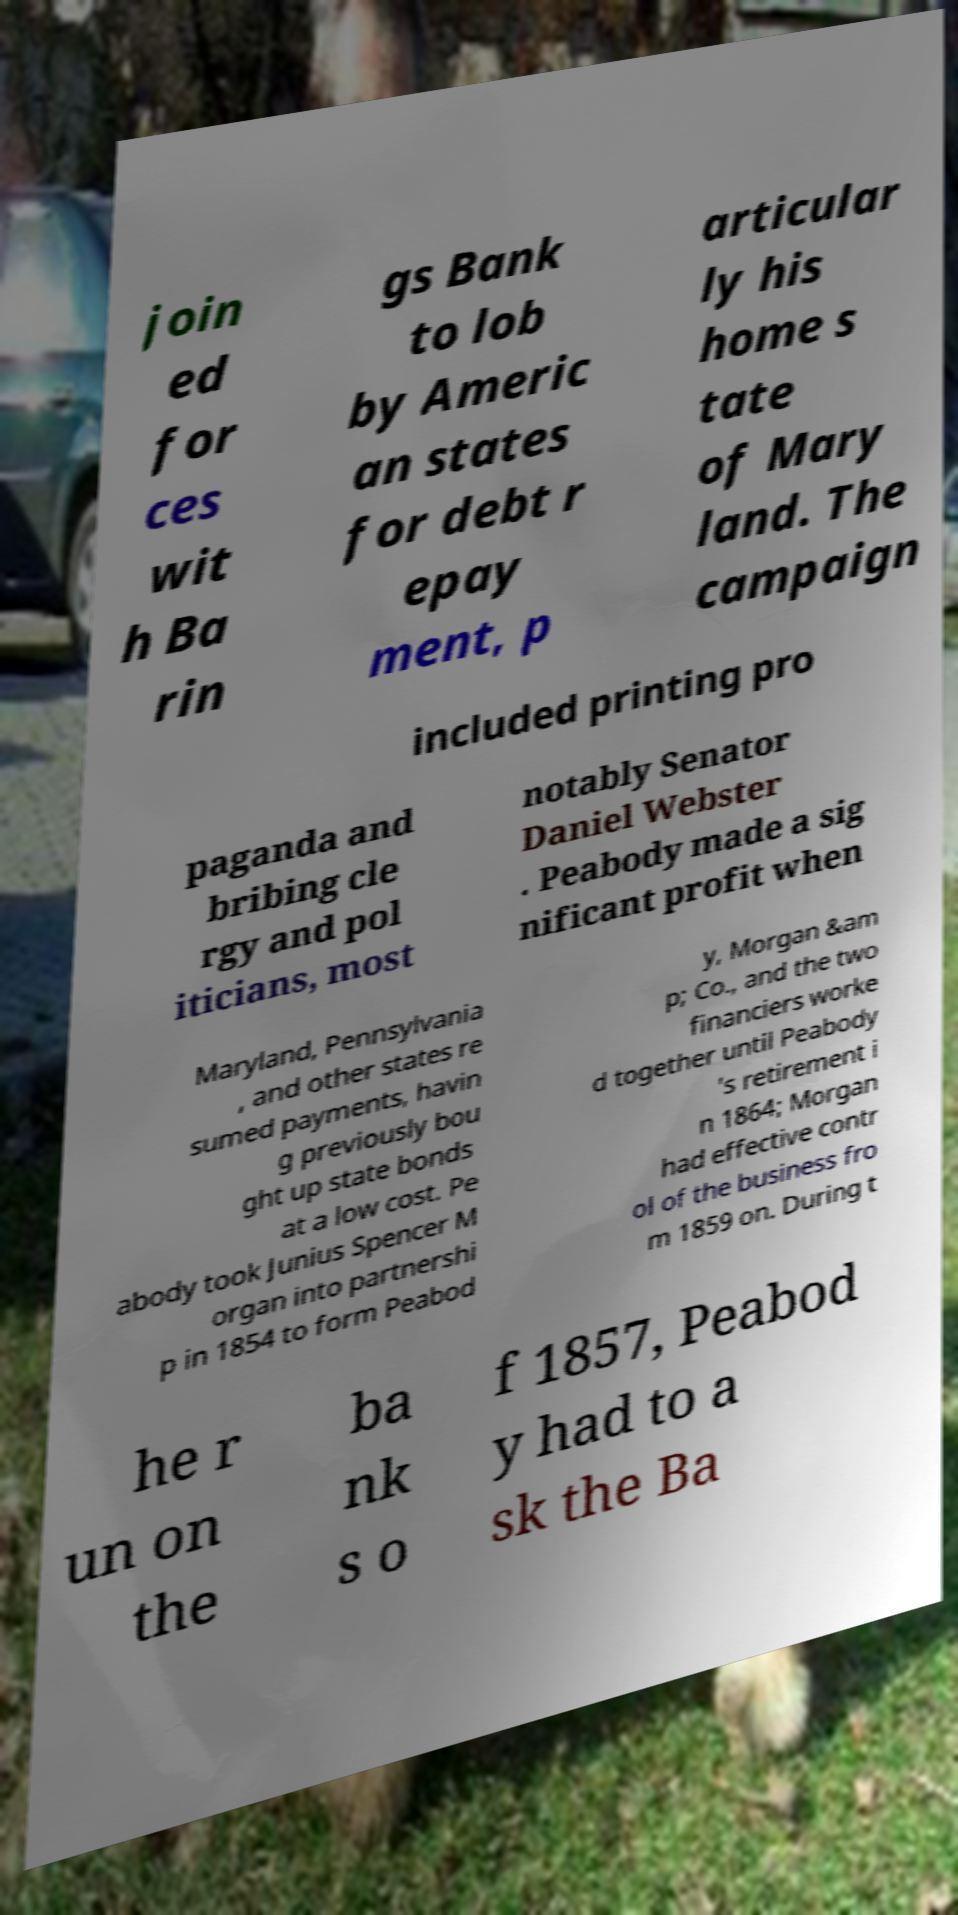Please read and relay the text visible in this image. What does it say? join ed for ces wit h Ba rin gs Bank to lob by Americ an states for debt r epay ment, p articular ly his home s tate of Mary land. The campaign included printing pro paganda and bribing cle rgy and pol iticians, most notably Senator Daniel Webster . Peabody made a sig nificant profit when Maryland, Pennsylvania , and other states re sumed payments, havin g previously bou ght up state bonds at a low cost. Pe abody took Junius Spencer M organ into partnershi p in 1854 to form Peabod y, Morgan &am p; Co., and the two financiers worke d together until Peabody 's retirement i n 1864; Morgan had effective contr ol of the business fro m 1859 on. During t he r un on the ba nk s o f 1857, Peabod y had to a sk the Ba 